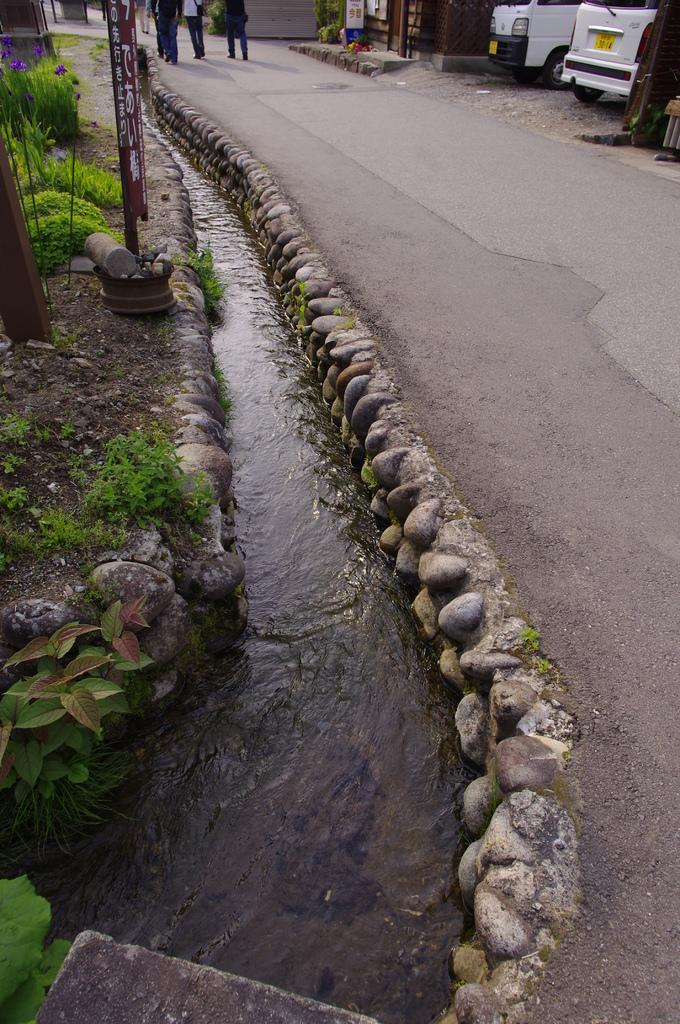Describe this image in one or two sentences. In this image, I can see water flowing, pants, poles and rocks. At the top of the image, there are group of people standing on the road. At the top right side of the image, there are two vehicles, which are parked. 